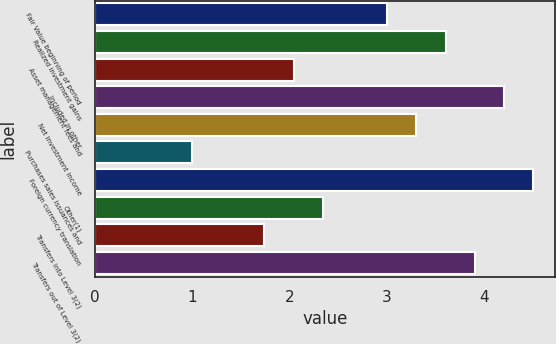Convert chart to OTSL. <chart><loc_0><loc_0><loc_500><loc_500><bar_chart><fcel>Fair Value beginning of period<fcel>Realized investment gains<fcel>Asset management fees and<fcel>Included in other<fcel>Net investment income<fcel>Purchases sales issuances and<fcel>Foreign currency translation<fcel>Other(1)<fcel>Transfers into Level 3(2)<fcel>Transfers out of Level 3(2)<nl><fcel>3<fcel>3.6<fcel>2.04<fcel>4.2<fcel>3.3<fcel>1<fcel>4.5<fcel>2.34<fcel>1.74<fcel>3.9<nl></chart> 